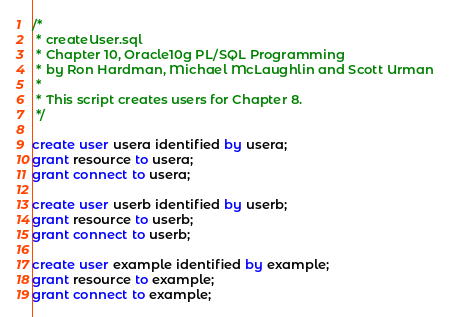Convert code to text. <code><loc_0><loc_0><loc_500><loc_500><_SQL_>/*
 * createUser.sql
 * Chapter 10, Oracle10g PL/SQL Programming
 * by Ron Hardman, Michael McLaughlin and Scott Urman
 *
 * This script creates users for Chapter 8.
 */

create user usera identified by usera;
grant resource to usera;
grant connect to usera;

create user userb identified by userb;
grant resource to userb;
grant connect to userb;

create user example identified by example;
grant resource to example;
grant connect to example;
</code> 